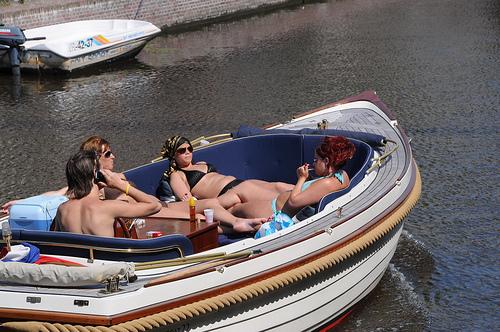Is it warm outside?
Quick response, please. Yes. Are these people relaxing?
Write a very short answer. Yes. What are they in?
Be succinct. Boat. 